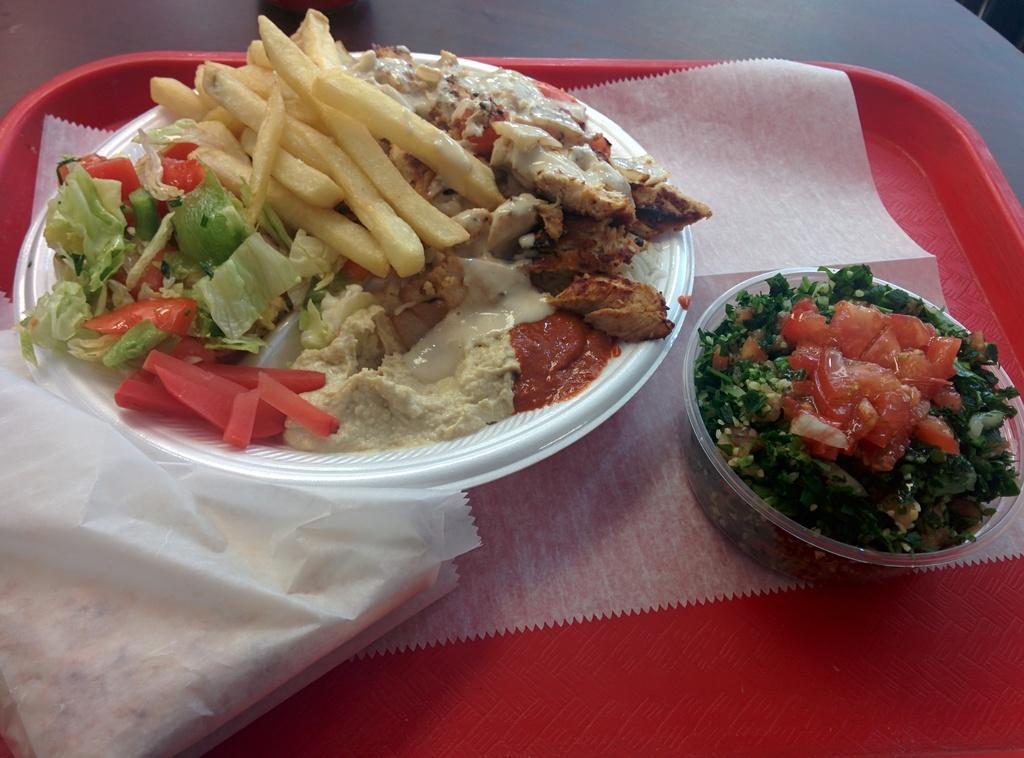Could you give a brief overview of what you see in this image? It is a zoom in picture of food items placed in a red color plate and the plate is placed on the surface. Food items include french fries, tomato slices, chopped coriander. 